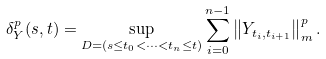Convert formula to latex. <formula><loc_0><loc_0><loc_500><loc_500>\delta _ { Y } ^ { p } ( s , t ) = \sup _ { D = ( s \leq t _ { 0 } < \cdots < t _ { n } \leq t ) } \sum _ { i = 0 } ^ { n - 1 } \left \| Y _ { t _ { i } , t _ { i + 1 } } \right \| _ { m } ^ { p } .</formula> 